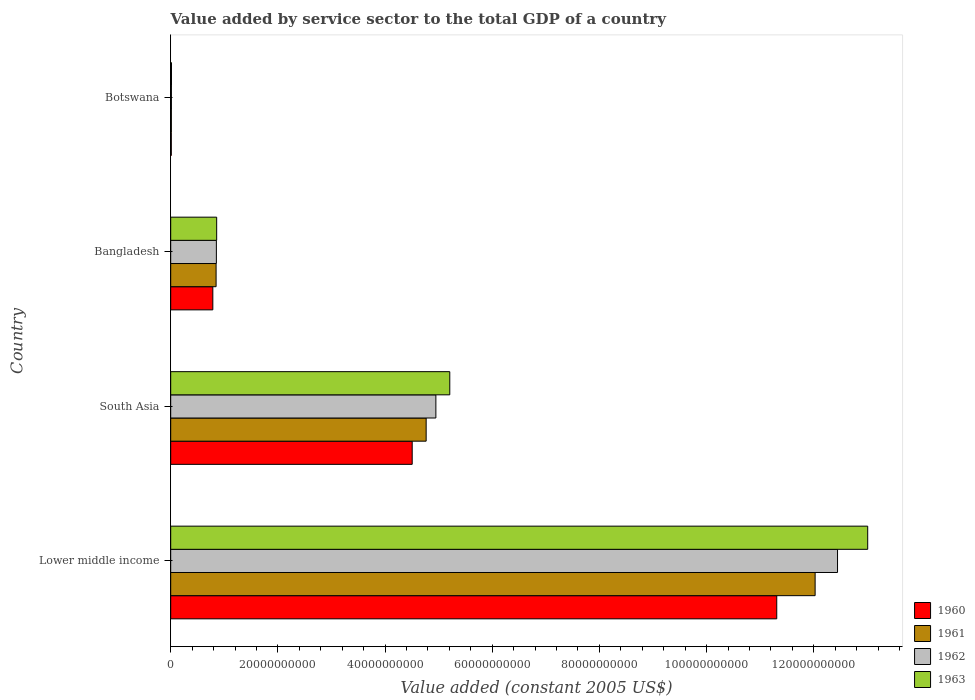How many different coloured bars are there?
Offer a very short reply. 4. Are the number of bars per tick equal to the number of legend labels?
Keep it short and to the point. Yes. Are the number of bars on each tick of the Y-axis equal?
Offer a very short reply. Yes. How many bars are there on the 4th tick from the top?
Make the answer very short. 4. What is the value added by service sector in 1960 in Botswana?
Your response must be concise. 1.11e+08. Across all countries, what is the maximum value added by service sector in 1962?
Your answer should be compact. 1.24e+11. Across all countries, what is the minimum value added by service sector in 1961?
Make the answer very short. 1.22e+08. In which country was the value added by service sector in 1962 maximum?
Keep it short and to the point. Lower middle income. In which country was the value added by service sector in 1963 minimum?
Offer a terse response. Botswana. What is the total value added by service sector in 1962 in the graph?
Provide a succinct answer. 1.83e+11. What is the difference between the value added by service sector in 1960 in Botswana and that in Lower middle income?
Your answer should be compact. -1.13e+11. What is the difference between the value added by service sector in 1963 in South Asia and the value added by service sector in 1960 in Lower middle income?
Offer a terse response. -6.10e+1. What is the average value added by service sector in 1960 per country?
Provide a short and direct response. 4.15e+1. What is the difference between the value added by service sector in 1960 and value added by service sector in 1961 in Botswana?
Offer a terse response. -1.12e+07. What is the ratio of the value added by service sector in 1961 in Lower middle income to that in South Asia?
Offer a terse response. 2.52. Is the difference between the value added by service sector in 1960 in Botswana and South Asia greater than the difference between the value added by service sector in 1961 in Botswana and South Asia?
Provide a short and direct response. Yes. What is the difference between the highest and the second highest value added by service sector in 1961?
Your answer should be compact. 7.26e+1. What is the difference between the highest and the lowest value added by service sector in 1960?
Provide a succinct answer. 1.13e+11. In how many countries, is the value added by service sector in 1962 greater than the average value added by service sector in 1962 taken over all countries?
Your answer should be compact. 2. Is it the case that in every country, the sum of the value added by service sector in 1962 and value added by service sector in 1961 is greater than the sum of value added by service sector in 1960 and value added by service sector in 1963?
Ensure brevity in your answer.  No. What does the 4th bar from the top in Lower middle income represents?
Ensure brevity in your answer.  1960. How many countries are there in the graph?
Keep it short and to the point. 4. Are the values on the major ticks of X-axis written in scientific E-notation?
Provide a succinct answer. No. Does the graph contain any zero values?
Offer a terse response. No. Does the graph contain grids?
Make the answer very short. No. How are the legend labels stacked?
Give a very brief answer. Vertical. What is the title of the graph?
Provide a succinct answer. Value added by service sector to the total GDP of a country. What is the label or title of the X-axis?
Your answer should be compact. Value added (constant 2005 US$). What is the label or title of the Y-axis?
Provide a short and direct response. Country. What is the Value added (constant 2005 US$) of 1960 in Lower middle income?
Offer a terse response. 1.13e+11. What is the Value added (constant 2005 US$) in 1961 in Lower middle income?
Ensure brevity in your answer.  1.20e+11. What is the Value added (constant 2005 US$) in 1962 in Lower middle income?
Keep it short and to the point. 1.24e+11. What is the Value added (constant 2005 US$) in 1963 in Lower middle income?
Provide a succinct answer. 1.30e+11. What is the Value added (constant 2005 US$) in 1960 in South Asia?
Provide a short and direct response. 4.51e+1. What is the Value added (constant 2005 US$) in 1961 in South Asia?
Offer a terse response. 4.77e+1. What is the Value added (constant 2005 US$) of 1962 in South Asia?
Provide a short and direct response. 4.95e+1. What is the Value added (constant 2005 US$) in 1963 in South Asia?
Keep it short and to the point. 5.21e+1. What is the Value added (constant 2005 US$) of 1960 in Bangladesh?
Provide a succinct answer. 7.86e+09. What is the Value added (constant 2005 US$) of 1961 in Bangladesh?
Offer a terse response. 8.47e+09. What is the Value added (constant 2005 US$) of 1962 in Bangladesh?
Provide a short and direct response. 8.52e+09. What is the Value added (constant 2005 US$) in 1963 in Bangladesh?
Your answer should be compact. 8.58e+09. What is the Value added (constant 2005 US$) of 1960 in Botswana?
Ensure brevity in your answer.  1.11e+08. What is the Value added (constant 2005 US$) in 1961 in Botswana?
Make the answer very short. 1.22e+08. What is the Value added (constant 2005 US$) of 1962 in Botswana?
Offer a terse response. 1.32e+08. What is the Value added (constant 2005 US$) of 1963 in Botswana?
Ensure brevity in your answer.  1.45e+08. Across all countries, what is the maximum Value added (constant 2005 US$) in 1960?
Provide a succinct answer. 1.13e+11. Across all countries, what is the maximum Value added (constant 2005 US$) in 1961?
Provide a short and direct response. 1.20e+11. Across all countries, what is the maximum Value added (constant 2005 US$) in 1962?
Provide a short and direct response. 1.24e+11. Across all countries, what is the maximum Value added (constant 2005 US$) in 1963?
Your response must be concise. 1.30e+11. Across all countries, what is the minimum Value added (constant 2005 US$) in 1960?
Make the answer very short. 1.11e+08. Across all countries, what is the minimum Value added (constant 2005 US$) of 1961?
Your answer should be compact. 1.22e+08. Across all countries, what is the minimum Value added (constant 2005 US$) in 1962?
Keep it short and to the point. 1.32e+08. Across all countries, what is the minimum Value added (constant 2005 US$) in 1963?
Ensure brevity in your answer.  1.45e+08. What is the total Value added (constant 2005 US$) of 1960 in the graph?
Ensure brevity in your answer.  1.66e+11. What is the total Value added (constant 2005 US$) in 1961 in the graph?
Ensure brevity in your answer.  1.77e+11. What is the total Value added (constant 2005 US$) of 1962 in the graph?
Provide a short and direct response. 1.83e+11. What is the total Value added (constant 2005 US$) in 1963 in the graph?
Offer a very short reply. 1.91e+11. What is the difference between the Value added (constant 2005 US$) of 1960 in Lower middle income and that in South Asia?
Provide a short and direct response. 6.80e+1. What is the difference between the Value added (constant 2005 US$) in 1961 in Lower middle income and that in South Asia?
Your answer should be compact. 7.26e+1. What is the difference between the Value added (constant 2005 US$) in 1962 in Lower middle income and that in South Asia?
Give a very brief answer. 7.50e+1. What is the difference between the Value added (constant 2005 US$) in 1963 in Lower middle income and that in South Asia?
Your response must be concise. 7.80e+1. What is the difference between the Value added (constant 2005 US$) of 1960 in Lower middle income and that in Bangladesh?
Make the answer very short. 1.05e+11. What is the difference between the Value added (constant 2005 US$) of 1961 in Lower middle income and that in Bangladesh?
Your response must be concise. 1.12e+11. What is the difference between the Value added (constant 2005 US$) of 1962 in Lower middle income and that in Bangladesh?
Your answer should be very brief. 1.16e+11. What is the difference between the Value added (constant 2005 US$) of 1963 in Lower middle income and that in Bangladesh?
Offer a very short reply. 1.21e+11. What is the difference between the Value added (constant 2005 US$) in 1960 in Lower middle income and that in Botswana?
Provide a short and direct response. 1.13e+11. What is the difference between the Value added (constant 2005 US$) in 1961 in Lower middle income and that in Botswana?
Ensure brevity in your answer.  1.20e+11. What is the difference between the Value added (constant 2005 US$) in 1962 in Lower middle income and that in Botswana?
Your answer should be very brief. 1.24e+11. What is the difference between the Value added (constant 2005 US$) of 1963 in Lower middle income and that in Botswana?
Provide a succinct answer. 1.30e+11. What is the difference between the Value added (constant 2005 US$) in 1960 in South Asia and that in Bangladesh?
Your answer should be very brief. 3.72e+1. What is the difference between the Value added (constant 2005 US$) in 1961 in South Asia and that in Bangladesh?
Give a very brief answer. 3.92e+1. What is the difference between the Value added (constant 2005 US$) of 1962 in South Asia and that in Bangladesh?
Provide a succinct answer. 4.10e+1. What is the difference between the Value added (constant 2005 US$) in 1963 in South Asia and that in Bangladesh?
Provide a succinct answer. 4.35e+1. What is the difference between the Value added (constant 2005 US$) in 1960 in South Asia and that in Botswana?
Your answer should be very brief. 4.50e+1. What is the difference between the Value added (constant 2005 US$) of 1961 in South Asia and that in Botswana?
Keep it short and to the point. 4.75e+1. What is the difference between the Value added (constant 2005 US$) of 1962 in South Asia and that in Botswana?
Your answer should be very brief. 4.93e+1. What is the difference between the Value added (constant 2005 US$) in 1963 in South Asia and that in Botswana?
Make the answer very short. 5.19e+1. What is the difference between the Value added (constant 2005 US$) in 1960 in Bangladesh and that in Botswana?
Provide a short and direct response. 7.75e+09. What is the difference between the Value added (constant 2005 US$) of 1961 in Bangladesh and that in Botswana?
Offer a very short reply. 8.35e+09. What is the difference between the Value added (constant 2005 US$) in 1962 in Bangladesh and that in Botswana?
Your answer should be very brief. 8.39e+09. What is the difference between the Value added (constant 2005 US$) in 1963 in Bangladesh and that in Botswana?
Provide a short and direct response. 8.43e+09. What is the difference between the Value added (constant 2005 US$) of 1960 in Lower middle income and the Value added (constant 2005 US$) of 1961 in South Asia?
Ensure brevity in your answer.  6.54e+1. What is the difference between the Value added (constant 2005 US$) in 1960 in Lower middle income and the Value added (constant 2005 US$) in 1962 in South Asia?
Provide a succinct answer. 6.36e+1. What is the difference between the Value added (constant 2005 US$) of 1960 in Lower middle income and the Value added (constant 2005 US$) of 1963 in South Asia?
Offer a terse response. 6.10e+1. What is the difference between the Value added (constant 2005 US$) of 1961 in Lower middle income and the Value added (constant 2005 US$) of 1962 in South Asia?
Keep it short and to the point. 7.08e+1. What is the difference between the Value added (constant 2005 US$) in 1961 in Lower middle income and the Value added (constant 2005 US$) in 1963 in South Asia?
Offer a very short reply. 6.82e+1. What is the difference between the Value added (constant 2005 US$) in 1962 in Lower middle income and the Value added (constant 2005 US$) in 1963 in South Asia?
Offer a terse response. 7.24e+1. What is the difference between the Value added (constant 2005 US$) in 1960 in Lower middle income and the Value added (constant 2005 US$) in 1961 in Bangladesh?
Provide a succinct answer. 1.05e+11. What is the difference between the Value added (constant 2005 US$) in 1960 in Lower middle income and the Value added (constant 2005 US$) in 1962 in Bangladesh?
Your answer should be very brief. 1.05e+11. What is the difference between the Value added (constant 2005 US$) of 1960 in Lower middle income and the Value added (constant 2005 US$) of 1963 in Bangladesh?
Give a very brief answer. 1.05e+11. What is the difference between the Value added (constant 2005 US$) in 1961 in Lower middle income and the Value added (constant 2005 US$) in 1962 in Bangladesh?
Give a very brief answer. 1.12e+11. What is the difference between the Value added (constant 2005 US$) in 1961 in Lower middle income and the Value added (constant 2005 US$) in 1963 in Bangladesh?
Your answer should be compact. 1.12e+11. What is the difference between the Value added (constant 2005 US$) of 1962 in Lower middle income and the Value added (constant 2005 US$) of 1963 in Bangladesh?
Your response must be concise. 1.16e+11. What is the difference between the Value added (constant 2005 US$) in 1960 in Lower middle income and the Value added (constant 2005 US$) in 1961 in Botswana?
Your answer should be very brief. 1.13e+11. What is the difference between the Value added (constant 2005 US$) of 1960 in Lower middle income and the Value added (constant 2005 US$) of 1962 in Botswana?
Ensure brevity in your answer.  1.13e+11. What is the difference between the Value added (constant 2005 US$) in 1960 in Lower middle income and the Value added (constant 2005 US$) in 1963 in Botswana?
Your answer should be compact. 1.13e+11. What is the difference between the Value added (constant 2005 US$) of 1961 in Lower middle income and the Value added (constant 2005 US$) of 1962 in Botswana?
Provide a short and direct response. 1.20e+11. What is the difference between the Value added (constant 2005 US$) in 1961 in Lower middle income and the Value added (constant 2005 US$) in 1963 in Botswana?
Provide a succinct answer. 1.20e+11. What is the difference between the Value added (constant 2005 US$) of 1962 in Lower middle income and the Value added (constant 2005 US$) of 1963 in Botswana?
Your answer should be very brief. 1.24e+11. What is the difference between the Value added (constant 2005 US$) of 1960 in South Asia and the Value added (constant 2005 US$) of 1961 in Bangladesh?
Your answer should be compact. 3.66e+1. What is the difference between the Value added (constant 2005 US$) of 1960 in South Asia and the Value added (constant 2005 US$) of 1962 in Bangladesh?
Ensure brevity in your answer.  3.65e+1. What is the difference between the Value added (constant 2005 US$) of 1960 in South Asia and the Value added (constant 2005 US$) of 1963 in Bangladesh?
Ensure brevity in your answer.  3.65e+1. What is the difference between the Value added (constant 2005 US$) in 1961 in South Asia and the Value added (constant 2005 US$) in 1962 in Bangladesh?
Offer a very short reply. 3.91e+1. What is the difference between the Value added (constant 2005 US$) of 1961 in South Asia and the Value added (constant 2005 US$) of 1963 in Bangladesh?
Your answer should be very brief. 3.91e+1. What is the difference between the Value added (constant 2005 US$) in 1962 in South Asia and the Value added (constant 2005 US$) in 1963 in Bangladesh?
Offer a very short reply. 4.09e+1. What is the difference between the Value added (constant 2005 US$) of 1960 in South Asia and the Value added (constant 2005 US$) of 1961 in Botswana?
Offer a terse response. 4.49e+1. What is the difference between the Value added (constant 2005 US$) of 1960 in South Asia and the Value added (constant 2005 US$) of 1962 in Botswana?
Provide a short and direct response. 4.49e+1. What is the difference between the Value added (constant 2005 US$) of 1960 in South Asia and the Value added (constant 2005 US$) of 1963 in Botswana?
Ensure brevity in your answer.  4.49e+1. What is the difference between the Value added (constant 2005 US$) of 1961 in South Asia and the Value added (constant 2005 US$) of 1962 in Botswana?
Give a very brief answer. 4.75e+1. What is the difference between the Value added (constant 2005 US$) in 1961 in South Asia and the Value added (constant 2005 US$) in 1963 in Botswana?
Make the answer very short. 4.75e+1. What is the difference between the Value added (constant 2005 US$) in 1962 in South Asia and the Value added (constant 2005 US$) in 1963 in Botswana?
Provide a short and direct response. 4.93e+1. What is the difference between the Value added (constant 2005 US$) in 1960 in Bangladesh and the Value added (constant 2005 US$) in 1961 in Botswana?
Offer a very short reply. 7.74e+09. What is the difference between the Value added (constant 2005 US$) of 1960 in Bangladesh and the Value added (constant 2005 US$) of 1962 in Botswana?
Offer a very short reply. 7.73e+09. What is the difference between the Value added (constant 2005 US$) of 1960 in Bangladesh and the Value added (constant 2005 US$) of 1963 in Botswana?
Provide a short and direct response. 7.72e+09. What is the difference between the Value added (constant 2005 US$) in 1961 in Bangladesh and the Value added (constant 2005 US$) in 1962 in Botswana?
Provide a succinct answer. 8.34e+09. What is the difference between the Value added (constant 2005 US$) of 1961 in Bangladesh and the Value added (constant 2005 US$) of 1963 in Botswana?
Ensure brevity in your answer.  8.32e+09. What is the difference between the Value added (constant 2005 US$) of 1962 in Bangladesh and the Value added (constant 2005 US$) of 1963 in Botswana?
Your response must be concise. 8.38e+09. What is the average Value added (constant 2005 US$) in 1960 per country?
Provide a succinct answer. 4.15e+1. What is the average Value added (constant 2005 US$) of 1961 per country?
Keep it short and to the point. 4.41e+1. What is the average Value added (constant 2005 US$) in 1962 per country?
Offer a very short reply. 4.56e+1. What is the average Value added (constant 2005 US$) in 1963 per country?
Give a very brief answer. 4.77e+1. What is the difference between the Value added (constant 2005 US$) in 1960 and Value added (constant 2005 US$) in 1961 in Lower middle income?
Your answer should be very brief. -7.16e+09. What is the difference between the Value added (constant 2005 US$) of 1960 and Value added (constant 2005 US$) of 1962 in Lower middle income?
Offer a terse response. -1.13e+1. What is the difference between the Value added (constant 2005 US$) of 1960 and Value added (constant 2005 US$) of 1963 in Lower middle income?
Offer a very short reply. -1.70e+1. What is the difference between the Value added (constant 2005 US$) in 1961 and Value added (constant 2005 US$) in 1962 in Lower middle income?
Keep it short and to the point. -4.18e+09. What is the difference between the Value added (constant 2005 US$) in 1961 and Value added (constant 2005 US$) in 1963 in Lower middle income?
Make the answer very short. -9.81e+09. What is the difference between the Value added (constant 2005 US$) in 1962 and Value added (constant 2005 US$) in 1963 in Lower middle income?
Your response must be concise. -5.63e+09. What is the difference between the Value added (constant 2005 US$) of 1960 and Value added (constant 2005 US$) of 1961 in South Asia?
Your answer should be very brief. -2.61e+09. What is the difference between the Value added (constant 2005 US$) of 1960 and Value added (constant 2005 US$) of 1962 in South Asia?
Offer a very short reply. -4.42e+09. What is the difference between the Value added (constant 2005 US$) in 1960 and Value added (constant 2005 US$) in 1963 in South Asia?
Offer a terse response. -7.01e+09. What is the difference between the Value added (constant 2005 US$) in 1961 and Value added (constant 2005 US$) in 1962 in South Asia?
Offer a very short reply. -1.81e+09. What is the difference between the Value added (constant 2005 US$) of 1961 and Value added (constant 2005 US$) of 1963 in South Asia?
Make the answer very short. -4.41e+09. What is the difference between the Value added (constant 2005 US$) of 1962 and Value added (constant 2005 US$) of 1963 in South Asia?
Your response must be concise. -2.59e+09. What is the difference between the Value added (constant 2005 US$) in 1960 and Value added (constant 2005 US$) in 1961 in Bangladesh?
Ensure brevity in your answer.  -6.09e+08. What is the difference between the Value added (constant 2005 US$) of 1960 and Value added (constant 2005 US$) of 1962 in Bangladesh?
Ensure brevity in your answer.  -6.62e+08. What is the difference between the Value added (constant 2005 US$) in 1960 and Value added (constant 2005 US$) in 1963 in Bangladesh?
Ensure brevity in your answer.  -7.16e+08. What is the difference between the Value added (constant 2005 US$) in 1961 and Value added (constant 2005 US$) in 1962 in Bangladesh?
Provide a short and direct response. -5.33e+07. What is the difference between the Value added (constant 2005 US$) of 1961 and Value added (constant 2005 US$) of 1963 in Bangladesh?
Your answer should be very brief. -1.08e+08. What is the difference between the Value added (constant 2005 US$) in 1962 and Value added (constant 2005 US$) in 1963 in Bangladesh?
Your answer should be compact. -5.45e+07. What is the difference between the Value added (constant 2005 US$) of 1960 and Value added (constant 2005 US$) of 1961 in Botswana?
Provide a succinct answer. -1.12e+07. What is the difference between the Value added (constant 2005 US$) of 1960 and Value added (constant 2005 US$) of 1962 in Botswana?
Provide a succinct answer. -2.17e+07. What is the difference between the Value added (constant 2005 US$) in 1960 and Value added (constant 2005 US$) in 1963 in Botswana?
Provide a short and direct response. -3.45e+07. What is the difference between the Value added (constant 2005 US$) in 1961 and Value added (constant 2005 US$) in 1962 in Botswana?
Ensure brevity in your answer.  -1.05e+07. What is the difference between the Value added (constant 2005 US$) of 1961 and Value added (constant 2005 US$) of 1963 in Botswana?
Your response must be concise. -2.33e+07. What is the difference between the Value added (constant 2005 US$) of 1962 and Value added (constant 2005 US$) of 1963 in Botswana?
Give a very brief answer. -1.28e+07. What is the ratio of the Value added (constant 2005 US$) in 1960 in Lower middle income to that in South Asia?
Offer a very short reply. 2.51. What is the ratio of the Value added (constant 2005 US$) of 1961 in Lower middle income to that in South Asia?
Your answer should be compact. 2.52. What is the ratio of the Value added (constant 2005 US$) in 1962 in Lower middle income to that in South Asia?
Provide a succinct answer. 2.51. What is the ratio of the Value added (constant 2005 US$) in 1963 in Lower middle income to that in South Asia?
Give a very brief answer. 2.5. What is the ratio of the Value added (constant 2005 US$) of 1960 in Lower middle income to that in Bangladesh?
Give a very brief answer. 14.39. What is the ratio of the Value added (constant 2005 US$) in 1961 in Lower middle income to that in Bangladesh?
Give a very brief answer. 14.2. What is the ratio of the Value added (constant 2005 US$) of 1962 in Lower middle income to that in Bangladesh?
Your answer should be compact. 14.6. What is the ratio of the Value added (constant 2005 US$) of 1963 in Lower middle income to that in Bangladesh?
Your answer should be very brief. 15.16. What is the ratio of the Value added (constant 2005 US$) of 1960 in Lower middle income to that in Botswana?
Provide a short and direct response. 1022.68. What is the ratio of the Value added (constant 2005 US$) in 1961 in Lower middle income to that in Botswana?
Keep it short and to the point. 987.49. What is the ratio of the Value added (constant 2005 US$) in 1962 in Lower middle income to that in Botswana?
Ensure brevity in your answer.  940.71. What is the ratio of the Value added (constant 2005 US$) of 1963 in Lower middle income to that in Botswana?
Provide a short and direct response. 896.5. What is the ratio of the Value added (constant 2005 US$) in 1960 in South Asia to that in Bangladesh?
Your answer should be compact. 5.73. What is the ratio of the Value added (constant 2005 US$) in 1961 in South Asia to that in Bangladesh?
Ensure brevity in your answer.  5.63. What is the ratio of the Value added (constant 2005 US$) of 1962 in South Asia to that in Bangladesh?
Give a very brief answer. 5.81. What is the ratio of the Value added (constant 2005 US$) of 1963 in South Asia to that in Bangladesh?
Your answer should be very brief. 6.07. What is the ratio of the Value added (constant 2005 US$) in 1960 in South Asia to that in Botswana?
Make the answer very short. 407.52. What is the ratio of the Value added (constant 2005 US$) of 1961 in South Asia to that in Botswana?
Make the answer very short. 391.45. What is the ratio of the Value added (constant 2005 US$) of 1962 in South Asia to that in Botswana?
Give a very brief answer. 374.08. What is the ratio of the Value added (constant 2005 US$) of 1963 in South Asia to that in Botswana?
Ensure brevity in your answer.  358.96. What is the ratio of the Value added (constant 2005 US$) in 1960 in Bangladesh to that in Botswana?
Provide a short and direct response. 71.09. What is the ratio of the Value added (constant 2005 US$) of 1961 in Bangladesh to that in Botswana?
Ensure brevity in your answer.  69.55. What is the ratio of the Value added (constant 2005 US$) in 1962 in Bangladesh to that in Botswana?
Offer a very short reply. 64.43. What is the ratio of the Value added (constant 2005 US$) in 1963 in Bangladesh to that in Botswana?
Offer a very short reply. 59.12. What is the difference between the highest and the second highest Value added (constant 2005 US$) of 1960?
Your response must be concise. 6.80e+1. What is the difference between the highest and the second highest Value added (constant 2005 US$) of 1961?
Provide a short and direct response. 7.26e+1. What is the difference between the highest and the second highest Value added (constant 2005 US$) of 1962?
Provide a short and direct response. 7.50e+1. What is the difference between the highest and the second highest Value added (constant 2005 US$) in 1963?
Provide a short and direct response. 7.80e+1. What is the difference between the highest and the lowest Value added (constant 2005 US$) of 1960?
Ensure brevity in your answer.  1.13e+11. What is the difference between the highest and the lowest Value added (constant 2005 US$) in 1961?
Ensure brevity in your answer.  1.20e+11. What is the difference between the highest and the lowest Value added (constant 2005 US$) in 1962?
Provide a short and direct response. 1.24e+11. What is the difference between the highest and the lowest Value added (constant 2005 US$) of 1963?
Keep it short and to the point. 1.30e+11. 